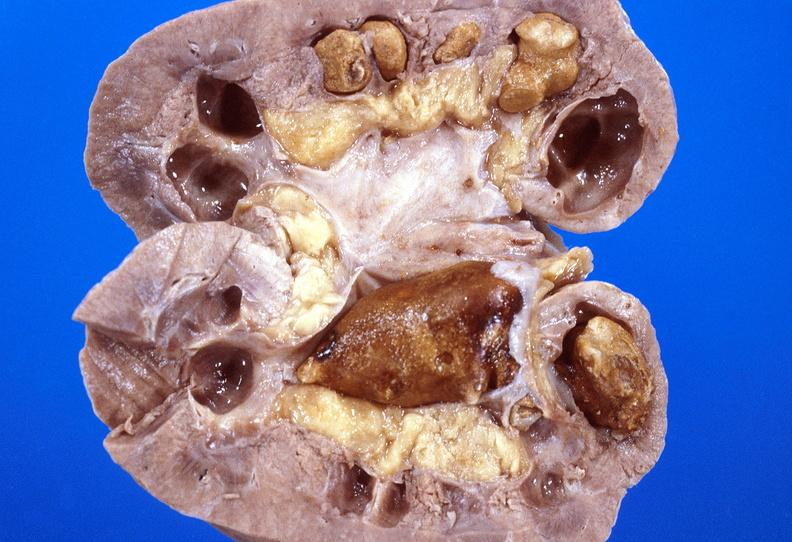what does this image show?
Answer the question using a single word or phrase. Kidney 